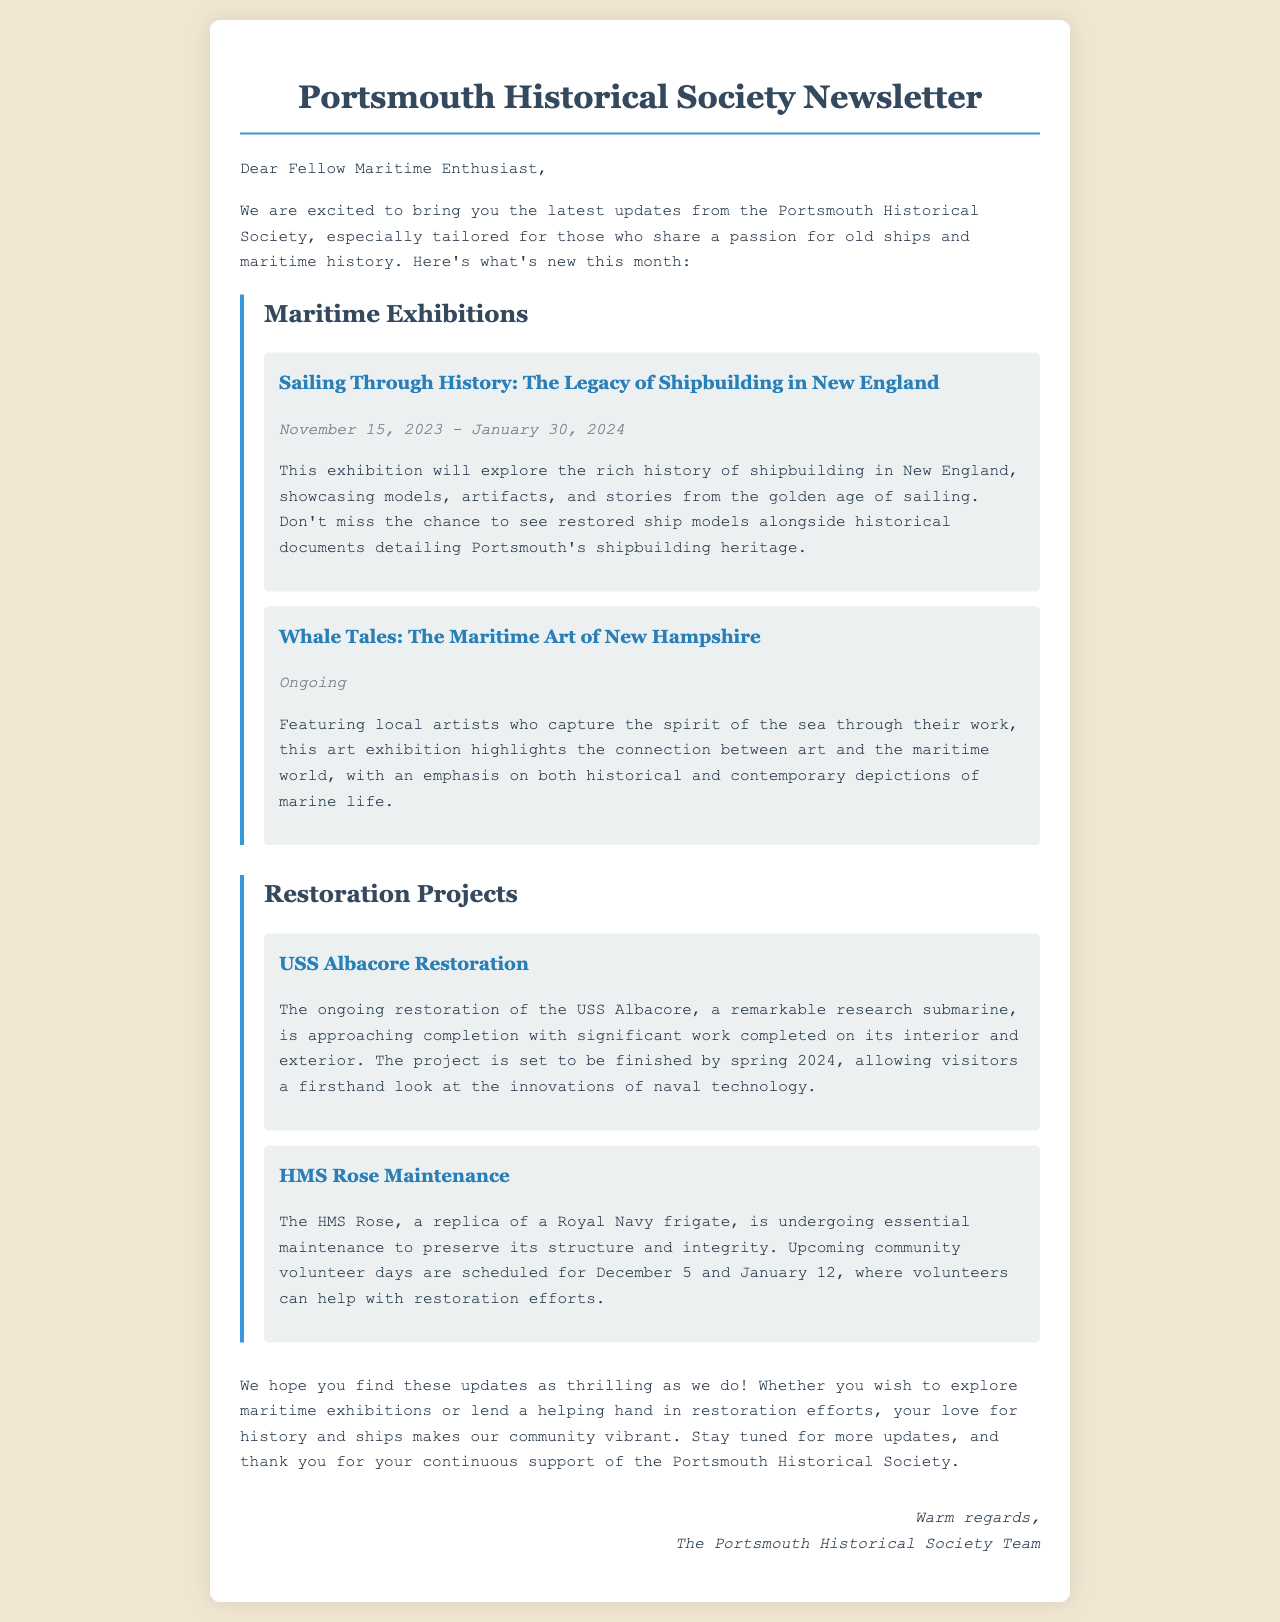What is the title of the upcoming exhibition? The title of the upcoming exhibition is provided in the section about maritime exhibitions, specifically "Sailing Through History: The Legacy of Shipbuilding in New England."
Answer: Sailing Through History: The Legacy of Shipbuilding in New England When does the USS Albacore restoration project finish? The document states that the USS Albacore restoration project is set to be finished by spring 2024.
Answer: Spring 2024 What type of naval vessel is the HMS Rose? The HMS Rose is described as a replica of a Royal Navy frigate in the restoration projects section of the document.
Answer: Replica of a Royal Navy frigate What are the dates for the community volunteer days for HMS Rose? The document provides specific dates for community volunteer days as December 5 and January 12.
Answer: December 5 and January 12 How long is the "Sailing Through History" exhibition open? The dates provided in the document indicate the exhibition is open from November 15, 2023, to January 30, 2024, which totals the number of days it will be available.
Answer: November 15, 2023 - January 30, 2024 What common theme do the exhibitions highlight? The exhibitions center around maritime history and art, as indicated by the content of both featured exhibitions focusing on maritime subjects.
Answer: Maritime history and art What is the contact for volunteering? The document does not explicitly state contact information for volunteering, focusing instead on the dates. Therefore, this question may not have an answer in the document.
Answer: Not provided Who is the newsletter addressed to? The greeting in the document indicates that the newsletter is addressed to "Dear Fellow Maritime Enthusiast."
Answer: Fellow Maritime Enthusiast 